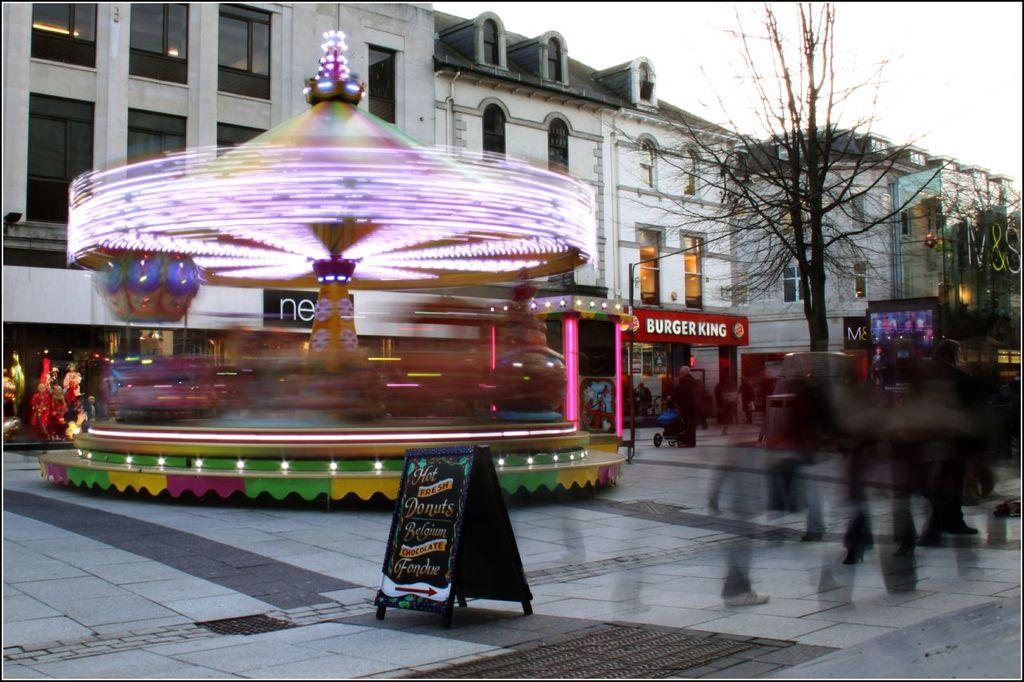<image>
Summarize the visual content of the image. The carousel goes so quickly but the burger king shop can still be seen in the background. 